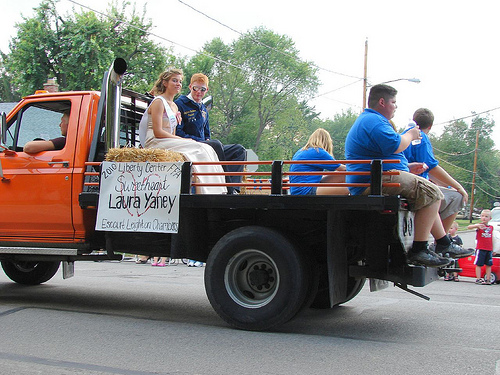<image>
Is there a person above the truck? No. The person is not positioned above the truck. The vertical arrangement shows a different relationship. 